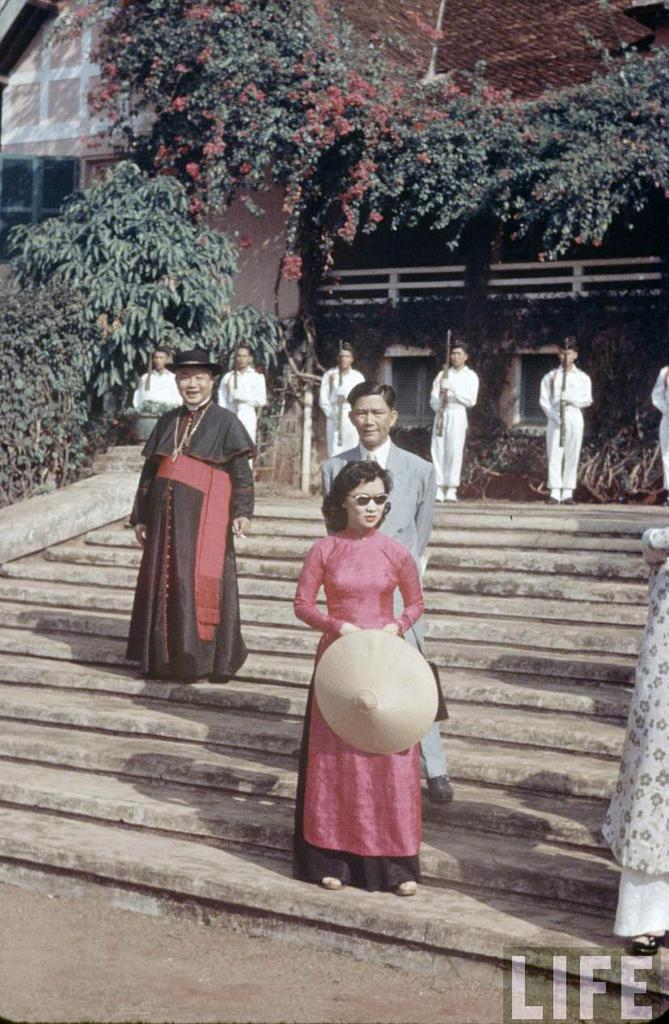What are the people in the image doing? Some of the people are holding guns, while others are standing on steps. Can you describe the location of the people in the image? The people are standing on steps, and there are trees and a building with windows visible in the background. What type of glue is being used to repair the hydrant in the image? There is no hydrant present in the image, and therefore no glue or repair work can be observed. Can you tell me how many wrenches are visible in the image? There are no wrenches visible in the image. 